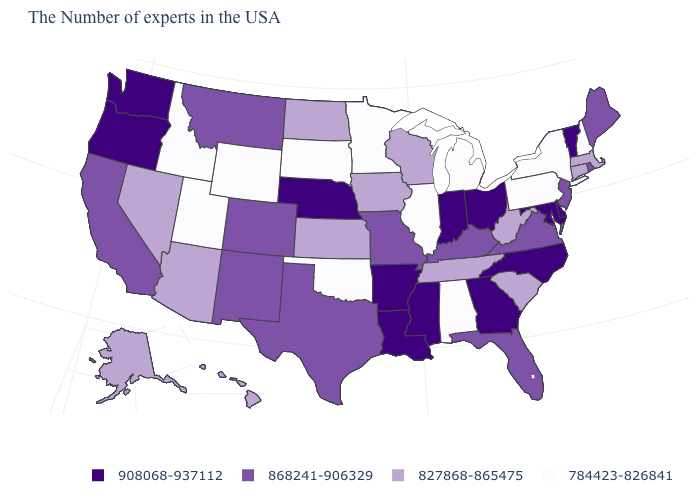What is the value of Washington?
Quick response, please. 908068-937112. Among the states that border North Carolina , which have the lowest value?
Give a very brief answer. South Carolina, Tennessee. Among the states that border Maine , which have the lowest value?
Concise answer only. New Hampshire. Among the states that border Massachusetts , which have the highest value?
Concise answer only. Vermont. What is the lowest value in the MidWest?
Give a very brief answer. 784423-826841. Name the states that have a value in the range 868241-906329?
Short answer required. Maine, Rhode Island, New Jersey, Virginia, Florida, Kentucky, Missouri, Texas, Colorado, New Mexico, Montana, California. Name the states that have a value in the range 908068-937112?
Quick response, please. Vermont, Delaware, Maryland, North Carolina, Ohio, Georgia, Indiana, Mississippi, Louisiana, Arkansas, Nebraska, Washington, Oregon. What is the value of Michigan?
Short answer required. 784423-826841. What is the highest value in states that border Delaware?
Give a very brief answer. 908068-937112. Does Kentucky have a lower value than Wisconsin?
Be succinct. No. Name the states that have a value in the range 784423-826841?
Concise answer only. New Hampshire, New York, Pennsylvania, Michigan, Alabama, Illinois, Minnesota, Oklahoma, South Dakota, Wyoming, Utah, Idaho. Among the states that border Massachusetts , which have the highest value?
Quick response, please. Vermont. Among the states that border Nevada , which have the highest value?
Write a very short answer. Oregon. Does Washington have a lower value than Michigan?
Give a very brief answer. No. What is the highest value in states that border Illinois?
Keep it brief. 908068-937112. 